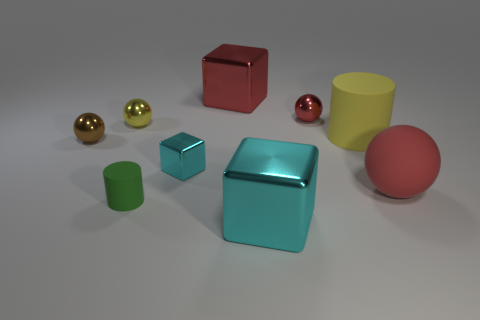Is there a big cube on the right side of the small thing that is in front of the cyan metallic thing that is behind the tiny green matte cylinder?
Offer a terse response. Yes. What number of brown spheres are behind the large cyan cube?
Give a very brief answer. 1. There is a thing that is the same color as the tiny metallic block; what is its material?
Make the answer very short. Metal. How many large things are cyan cylinders or red shiny balls?
Keep it short and to the point. 0. There is a rubber thing that is to the left of the large cylinder; what is its shape?
Your answer should be very brief. Cylinder. Are there any large matte things of the same color as the small block?
Give a very brief answer. No. Does the matte cylinder in front of the big yellow cylinder have the same size as the red sphere in front of the small yellow ball?
Provide a succinct answer. No. Are there more big things on the left side of the brown sphere than red objects in front of the large cyan object?
Offer a very short reply. No. Is there a yellow object that has the same material as the tiny cyan thing?
Offer a very short reply. Yes. Is the small rubber cylinder the same color as the small shiny cube?
Your response must be concise. No. 